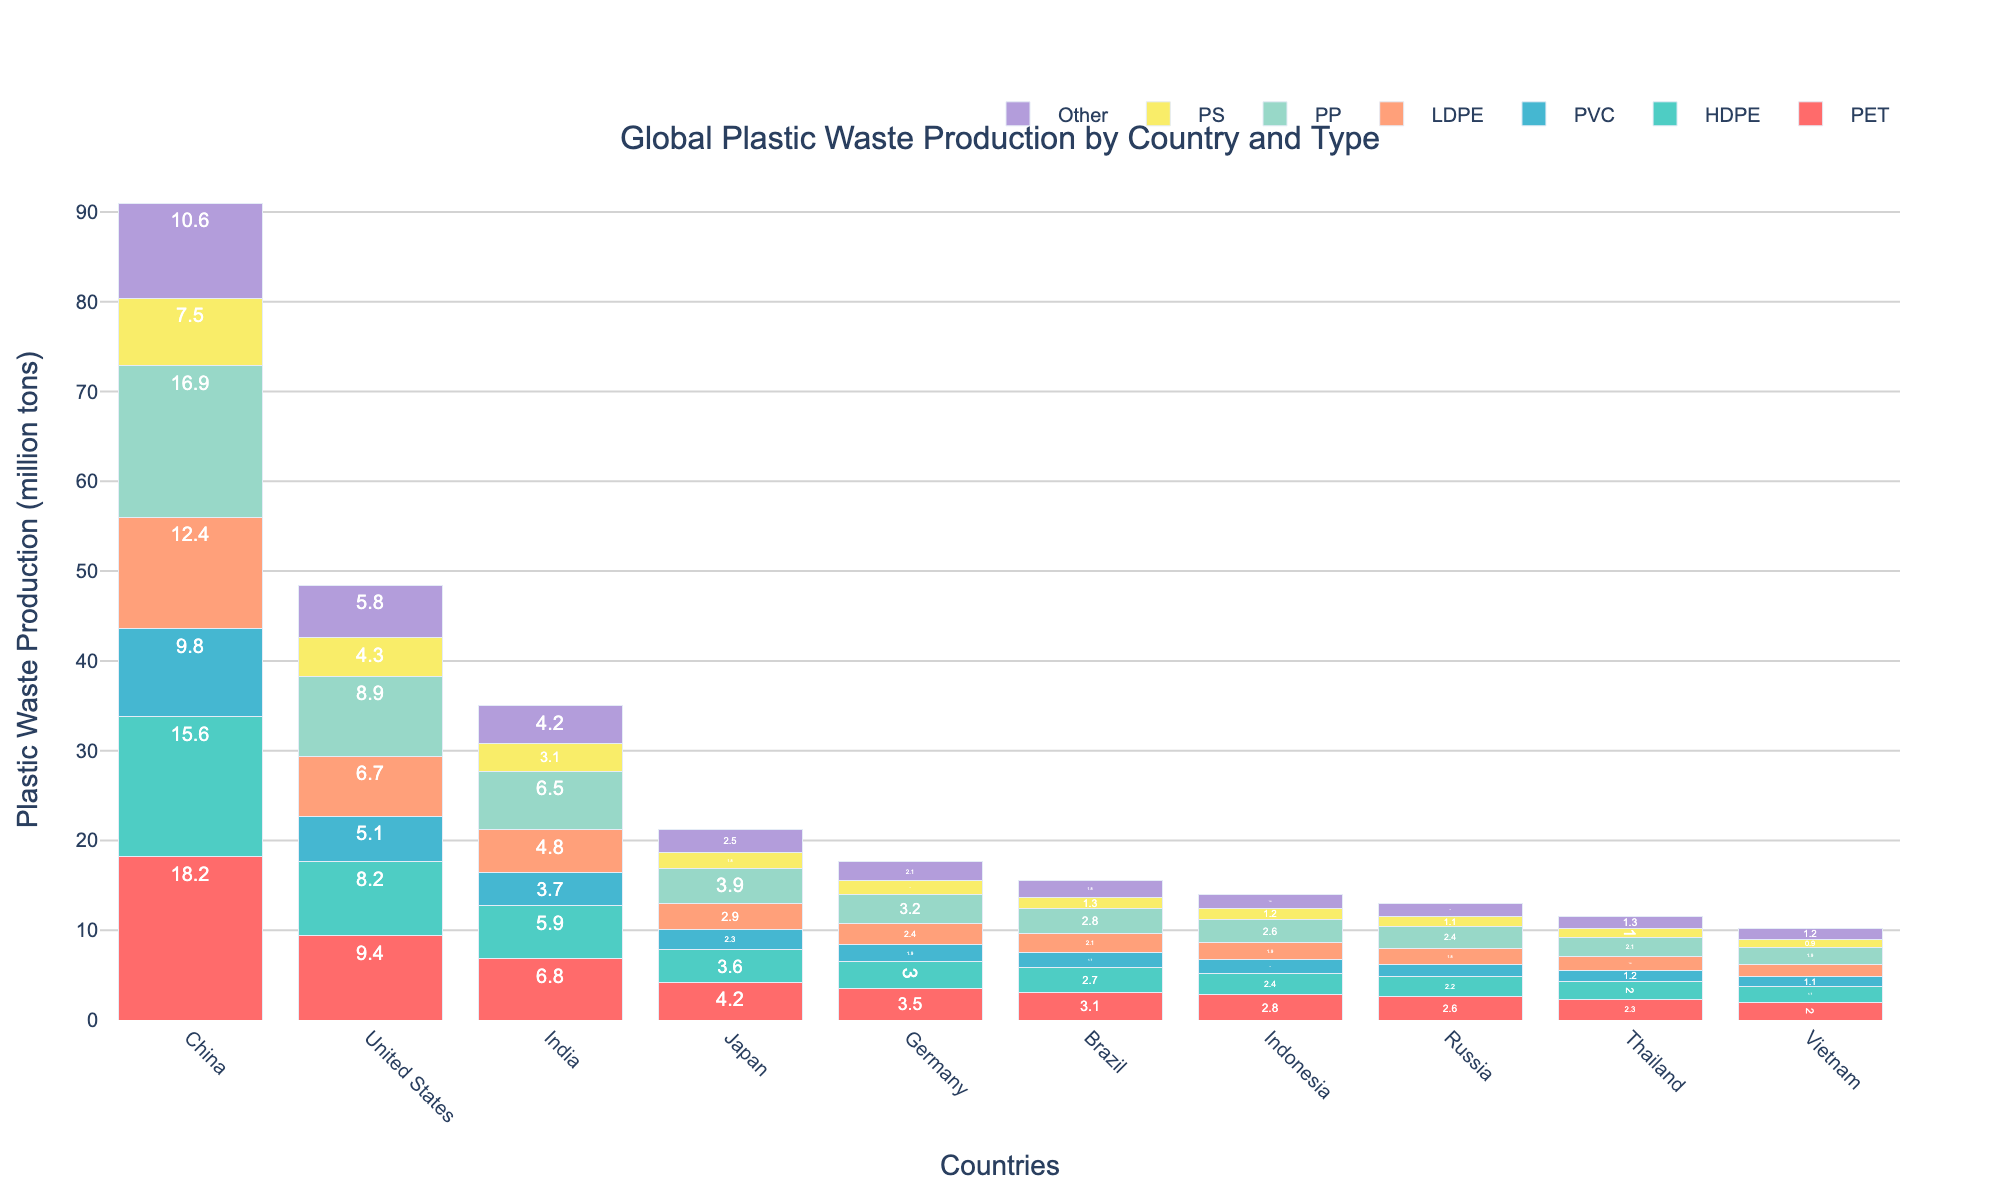Which country produces the most PET waste? Look at the bar representing PET production for each country and identify the tallest bar. China has the tallest bar for PET production.
Answer: China Which country produces the least PS waste? Compare the bars representing PS production for each country and identify the shortest bar. Vietnam has the shortest bar for PS production.
Answer: Vietnam What is the total plastic waste production of the United States? Sum the values of all types of plastic waste produced by the United States: (9.4 + 8.2 + 5.1 + 6.7 + 8.9 + 4.3 + 5.8), which is equal to 48.4.
Answer: 48.4 How does India’s PVC waste production compare to Brazil’s? Compare the height of the bar representing PVC production for India with that for Brazil. India's bar is taller than Brazil's bar.
Answer: Higher Which type of plastic has the most consistent production across all countries? Look at the bars of each type of plastic across all countries and identify which type has the most even heights. PET appears to be the most consistently produced type.
Answer: PET What is the difference in total plastic waste production between China and Japan? Sum all the values of plastic waste production for both China and Japan, then subtract: [(18.2 + 15.6 + 9.8 + 12.4 + 16.9 + 7.5 + 10.6) - (4.2 + 3.6 + 2.3 + 2.9 + 3.9 + 1.8 + 2.5)] = [91 - 21.2] = 69.8
Answer: 69.8 Which country has the higher production of LDPE plastic waste, Russia or Indonesia? Compare the heights of the LDPE waste production bars for Russia and Indonesia. Indonesia’s bar is slightly taller than Russia's.
Answer: Indonesia What is the average production of HDPE waste among all countries? Sum the HDPE values for all countries and divide by the number of countries: (15.6 + 8.2 + 5.9 + 3.6 + 3 + 2.7 + 2.4 + 2.2 + 2 + 1.7) / 10 = 47.3 / 10 = 4.73.
Answer: 4.73 For which type of plastic is Japan's production closest to Brazil's production? Compare each type of plastic waste production value for Japan and Brazil and identify the type with the smallest difference. Japan and Brazil are closest in their PVC production, with Japan at 2.3 and Brazil at 1.7.
Answer: PVC 